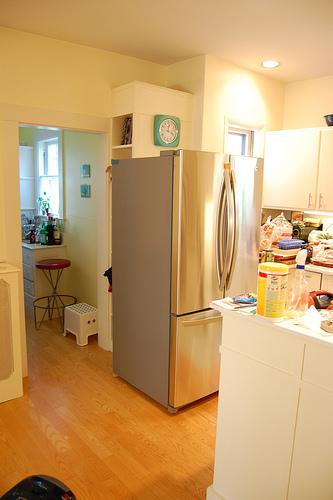Mention a few prominent objects in the photograph and their colors. Some noticeable objects in the image include a stainless steel fridge, a red bar stool, a white step stool, and a green framed clock on the wall. Briefly describe a decorative aspect of the image. Two small paintings and a green framed wall clock serve as decorative elements in the image. Provide a brief description of the central focus of the image. A stainless steel refrigerator stands in a kitchen, surrounded by various items such as a red stool, a white step stool, and counters with household items. List a few household items found on the counters in the image. Some items found on the counters include a tub of Clorox wipes, a clear empty spray bottle, a yellow plastic container, and a blue plastic container. What type of flooring is seen in the image, and what is the main kitchen appliance shown? The image showcases hardwood flooring and prominently features a stainless steel refrigerator as the main kitchen appliance. What are some seating options available in the kitchen? Seating options in the kitchen include a small red bar stool and a small white step stool. Mention an interesting detail about the refrigerator in the image. A green wall clock hangs above the large stainless steel refrigerator, adding a pop of color to the scene. Describe the setting in which the main object is placed. The stainless steel fridge is placed in a kitchen with hardwood floors, white cabinets, and a window with a plant in the windowsill. Enumerate some objects or decorations found on the walls in the image. A green framed clock, two small paintings, and a blue wall clock are some objects and decorations found on the walls. Detail the different items and furniture within the kitchen setting. Within the kitchen, there are a stainless steel refrigerator, a red bar stool, a white step stool, a window with a plant, and counters cluttered with various items. 